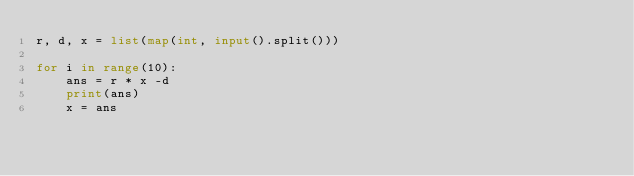Convert code to text. <code><loc_0><loc_0><loc_500><loc_500><_Python_>r, d, x = list(map(int, input().split()))

for i in range(10):
    ans = r * x -d
    print(ans)
    x = ans
</code> 